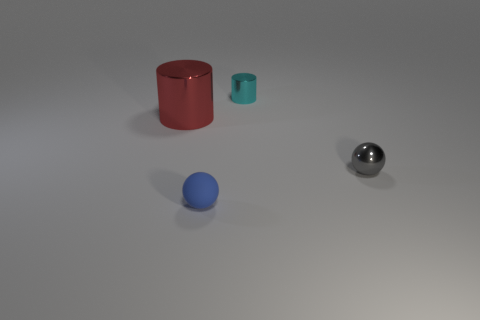The large object that is made of the same material as the tiny cyan object is what shape?
Provide a succinct answer. Cylinder. There is a metal thing on the right side of the tiny cyan thing; does it have the same shape as the tiny cyan thing?
Your answer should be very brief. No. What is the size of the metal cylinder that is on the right side of the red cylinder in front of the cyan cylinder?
Keep it short and to the point. Small. What color is the other cylinder that is the same material as the large cylinder?
Your answer should be very brief. Cyan. What number of other things have the same size as the blue rubber object?
Offer a terse response. 2. What number of green things are either matte objects or small spheres?
Give a very brief answer. 0. How many things are either big things or shiny cylinders that are to the right of the small matte ball?
Offer a terse response. 2. There is a ball left of the gray object; what is its material?
Give a very brief answer. Rubber. The cyan shiny thing that is the same size as the blue matte ball is what shape?
Provide a short and direct response. Cylinder. Is there another blue object of the same shape as the small blue matte thing?
Make the answer very short. No. 